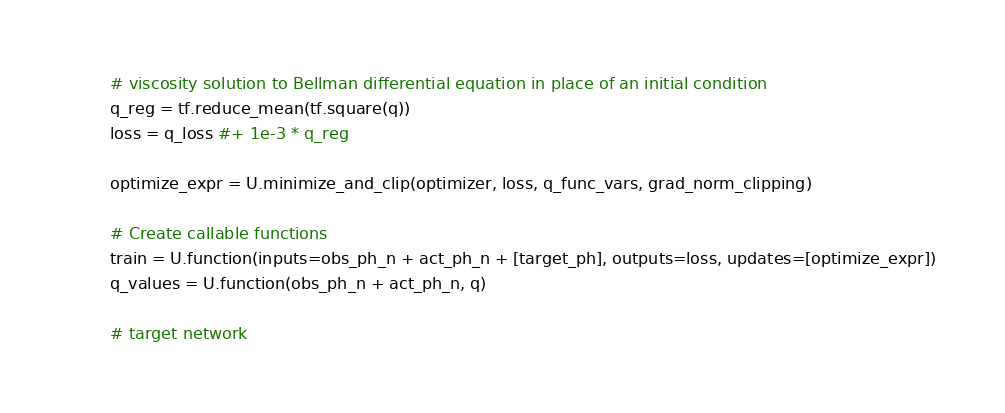Convert code to text. <code><loc_0><loc_0><loc_500><loc_500><_Python_>        # viscosity solution to Bellman differential equation in place of an initial condition
        q_reg = tf.reduce_mean(tf.square(q))
        loss = q_loss #+ 1e-3 * q_reg

        optimize_expr = U.minimize_and_clip(optimizer, loss, q_func_vars, grad_norm_clipping)

        # Create callable functions
        train = U.function(inputs=obs_ph_n + act_ph_n + [target_ph], outputs=loss, updates=[optimize_expr])
        q_values = U.function(obs_ph_n + act_ph_n, q)

        # target network</code> 